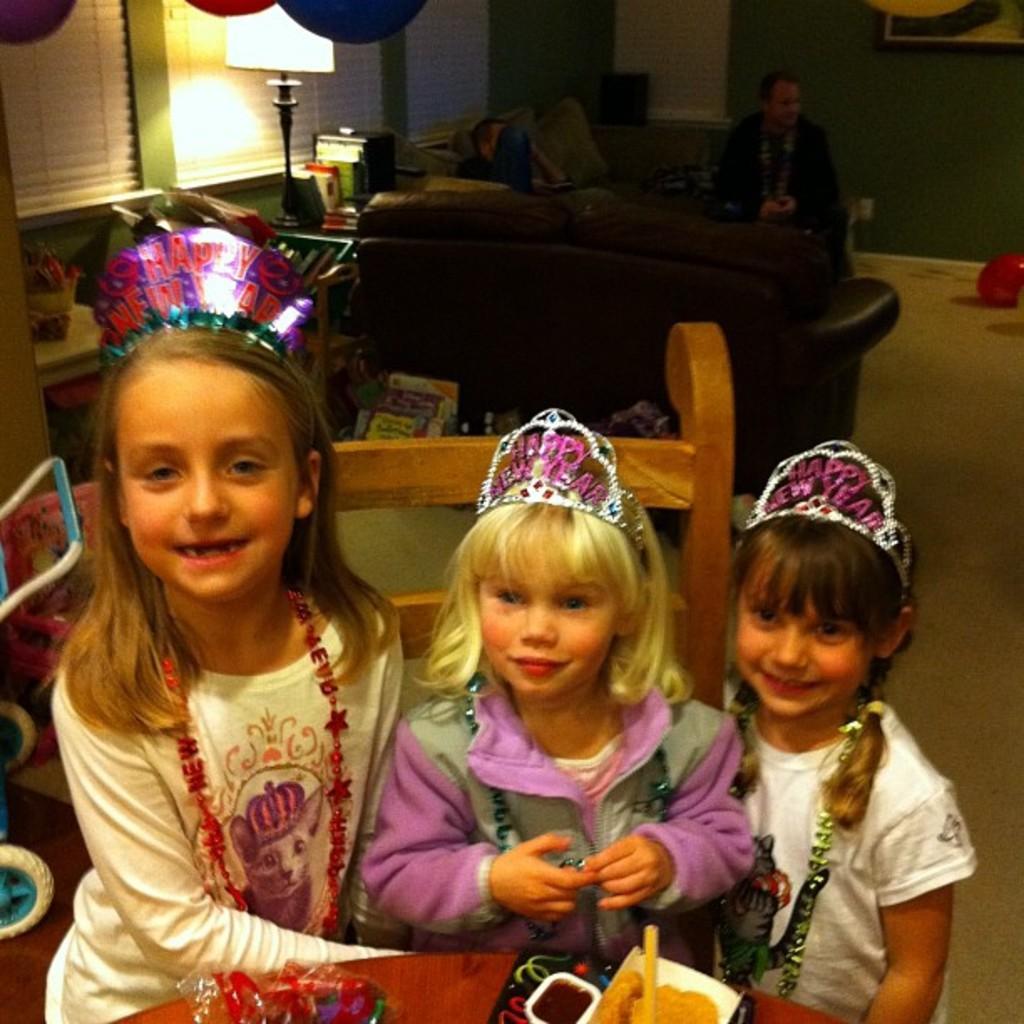Please provide a concise description of this image. In this image we can see there are three girls wearing a crown on their hand and sitting on the chair, in front of them there is a stuff on the table, behind them there is a person sat on the sofa, beside the sofa there is a lamp and other stuff. There are few objects placed on the floor. 